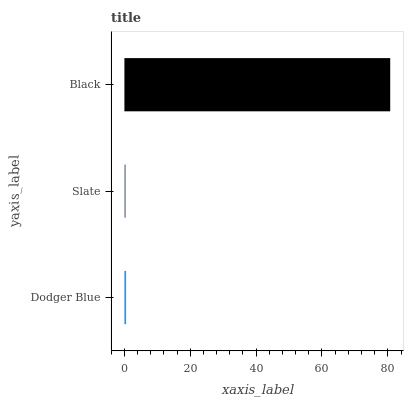Is Slate the minimum?
Answer yes or no. Yes. Is Black the maximum?
Answer yes or no. Yes. Is Black the minimum?
Answer yes or no. No. Is Slate the maximum?
Answer yes or no. No. Is Black greater than Slate?
Answer yes or no. Yes. Is Slate less than Black?
Answer yes or no. Yes. Is Slate greater than Black?
Answer yes or no. No. Is Black less than Slate?
Answer yes or no. No. Is Dodger Blue the high median?
Answer yes or no. Yes. Is Dodger Blue the low median?
Answer yes or no. Yes. Is Slate the high median?
Answer yes or no. No. Is Black the low median?
Answer yes or no. No. 